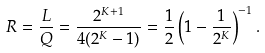<formula> <loc_0><loc_0><loc_500><loc_500>R = \frac { L } { Q } = \frac { 2 ^ { K + 1 } } { 4 ( 2 ^ { K } - 1 ) } = \frac { 1 } { 2 } \left ( 1 - \frac { 1 } { 2 ^ { K } } \right ) ^ { - 1 } .</formula> 